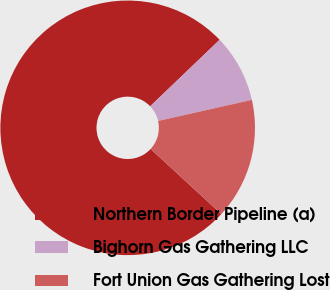Convert chart to OTSL. <chart><loc_0><loc_0><loc_500><loc_500><pie_chart><fcel>Northern Border Pipeline (a)<fcel>Bighorn Gas Gathering LLC<fcel>Fort Union Gas Gathering Lost<nl><fcel>76.0%<fcel>8.63%<fcel>15.37%<nl></chart> 